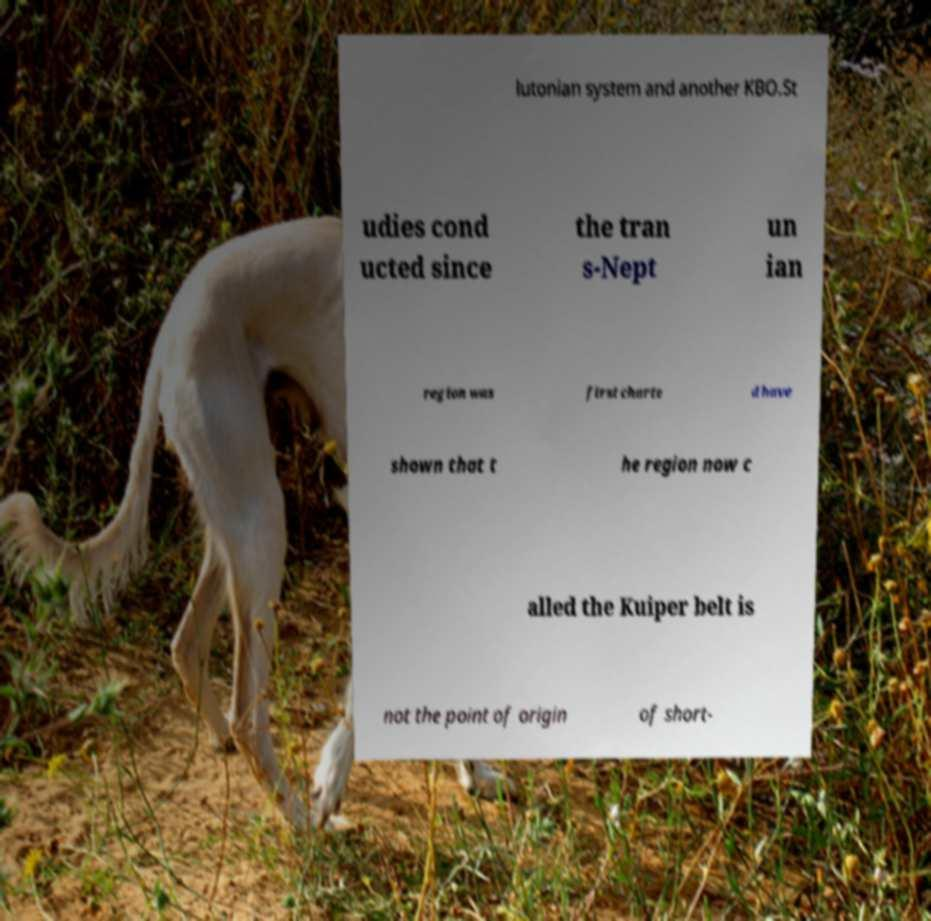What messages or text are displayed in this image? I need them in a readable, typed format. lutonian system and another KBO.St udies cond ucted since the tran s-Nept un ian region was first charte d have shown that t he region now c alled the Kuiper belt is not the point of origin of short- 